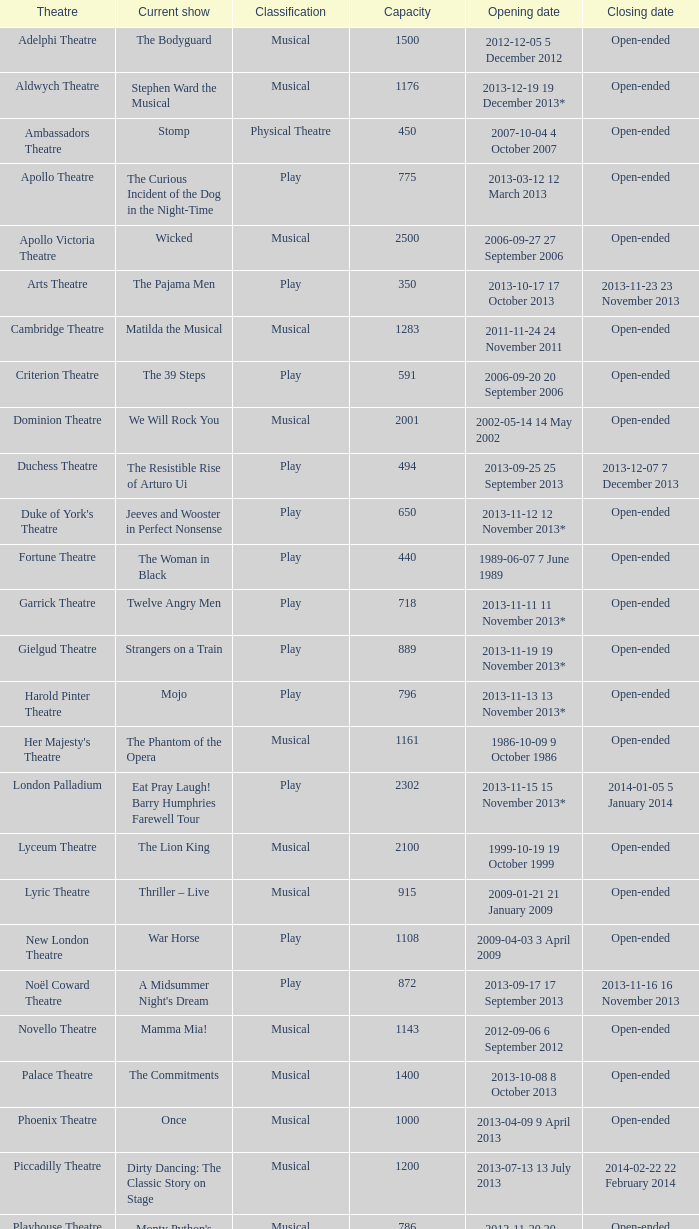When does the musical at the adelphi theatre begin? 2012-12-05 5 December 2012. 